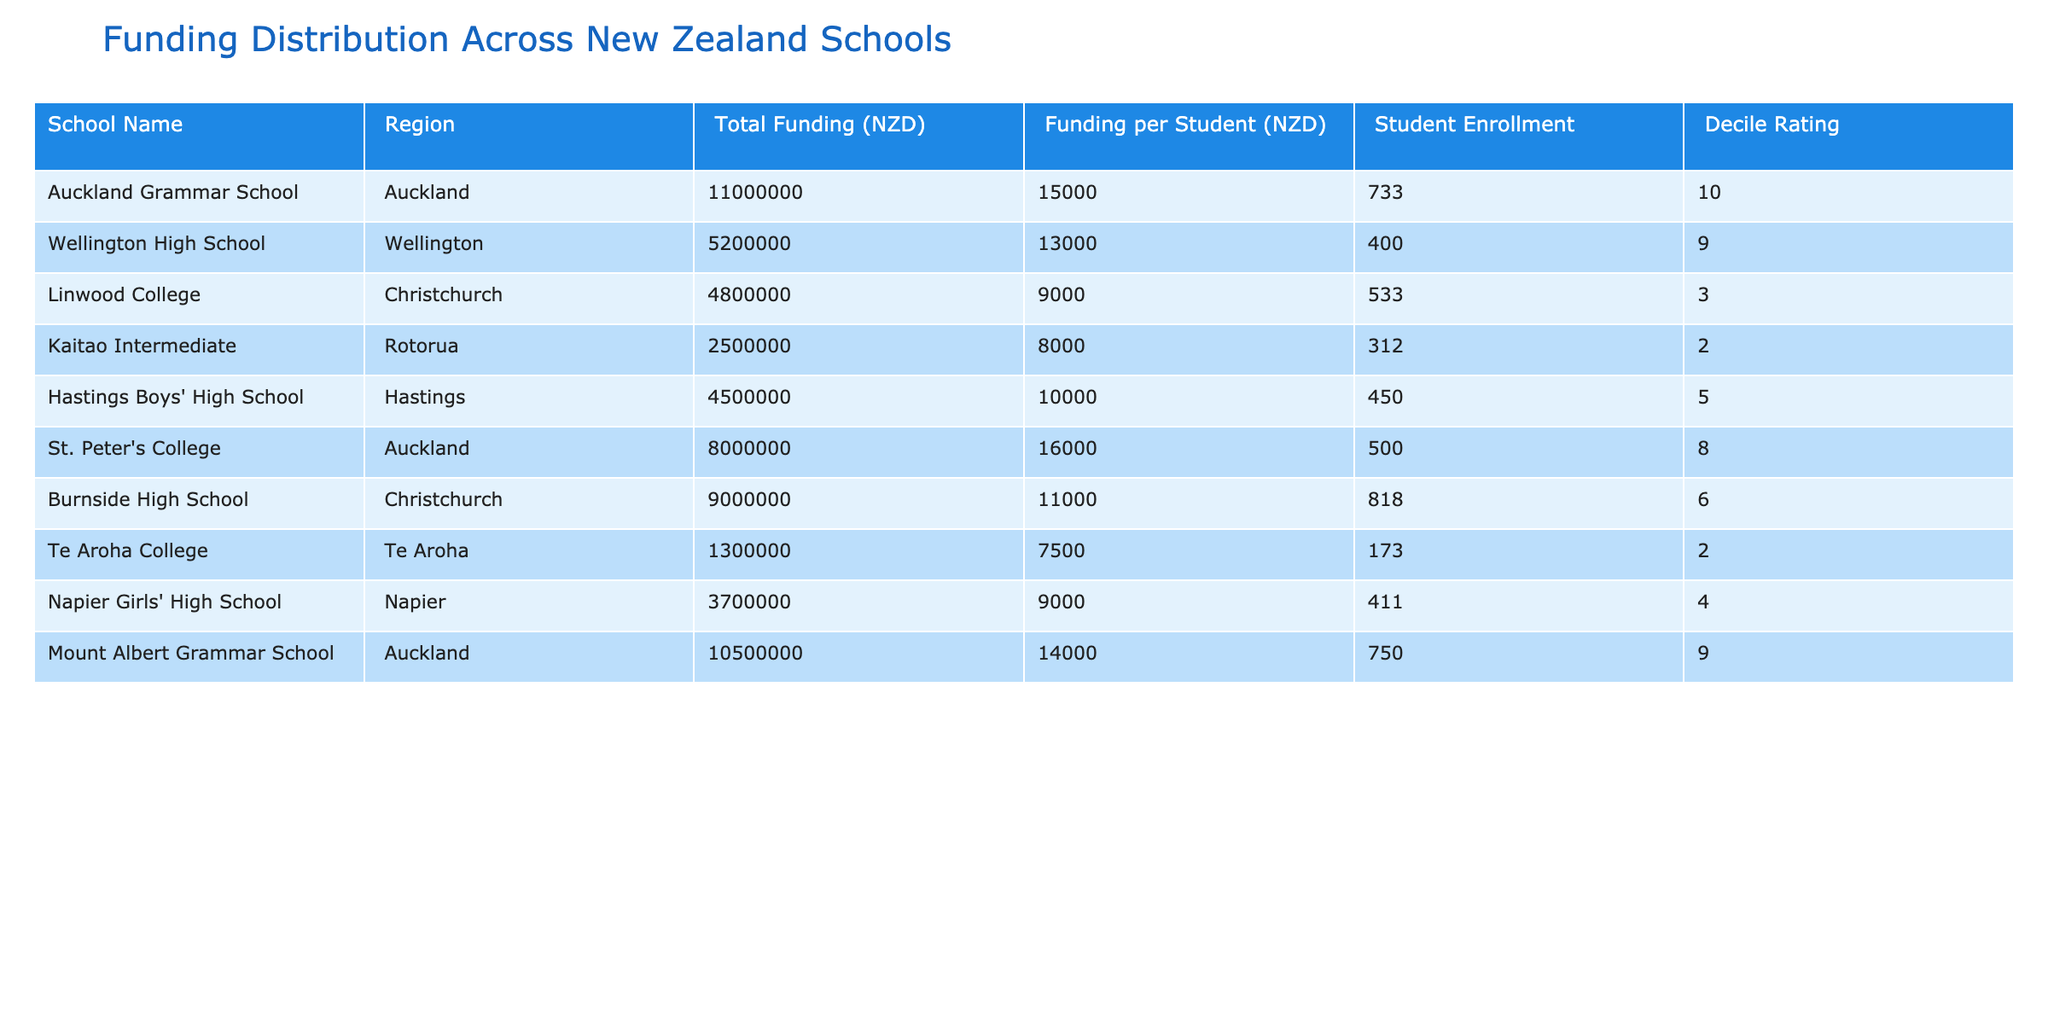What is the total funding for Auckland Grammar School? The table lists the Total Funding for Auckland Grammar School as 11,000,000 NZD.
Answer: 11,000,000 NZD Which school has the highest funding per student? By comparing the Funding per Student column, Auckland Grammar School has the highest value at 15,000 NZD.
Answer: Auckland Grammar School What is the average Funding per Student for all the schools? To find the average, sum the Funding per Student values: (15,000 + 13,000 + 9,000 + 8,000 + 10,000 + 16,000 + 11,000 + 7,500 + 9,000 + 14,000) = 12,600. There are 10 schools, so the average is 126,000 / 10 = 12,600 NZD.
Answer: 12,600 NZD Is Linwood College rated higher than Hastings Boys' High School? Linwood College has a decile rating of 3 while Hastings Boys' High School has a decile rating of 5. Since 5 is greater than 3, Linwood College is rated lower.
Answer: No How much funding is allocated to all schools with a decile rating of 2 or lower? Identifying the schools with a decile rating of 2 or lower: Kaitao Intermediate (2) with 2,500,000 NZD and Te Aroha College (2) with 1,300,000 NZD. Adding these gives total funding of (2,500,000 + 1,300,000) = 3,800,000 NZD.
Answer: 3,800,000 NZD What is the difference in total funding between St. Peter's College and Burnside High School? St. Peter's College has a total funding of 8,000,000 NZD while Burnside High School has 9,000,000 NZD. The difference is calculated as 9,000,000 - 8,000,000 = 1,000,000 NZD.
Answer: 1,000,000 NZD Do any schools have a decile rating of 10? Yes, Auckland Grammar School has a decile rating of 10.
Answer: Yes Which region has the lowest total funding across schools? Looking at the Total Funding for each region, Rotorua (Kaitao Intermediate) has the lowest funding at 2,500,000 NZD.
Answer: Rotorua What percentage of the total funding is allocated to Wellington High School? The total funding for all schools is calculated as 11,000,000 + 5,200,000 + 4,800,000 + 2,500,000 + 4,500,000 + 8,000,000 + 9,000,000 + 1,300,000 + 3,700,000 + 10,500,000 = 60,500,000 NZD. Wellington High School's funding is 5,200,000 NZD, then the percentage is (5,200,000 / 60,500,000) * 100 = approximately 8.60%.
Answer: 8.60% 